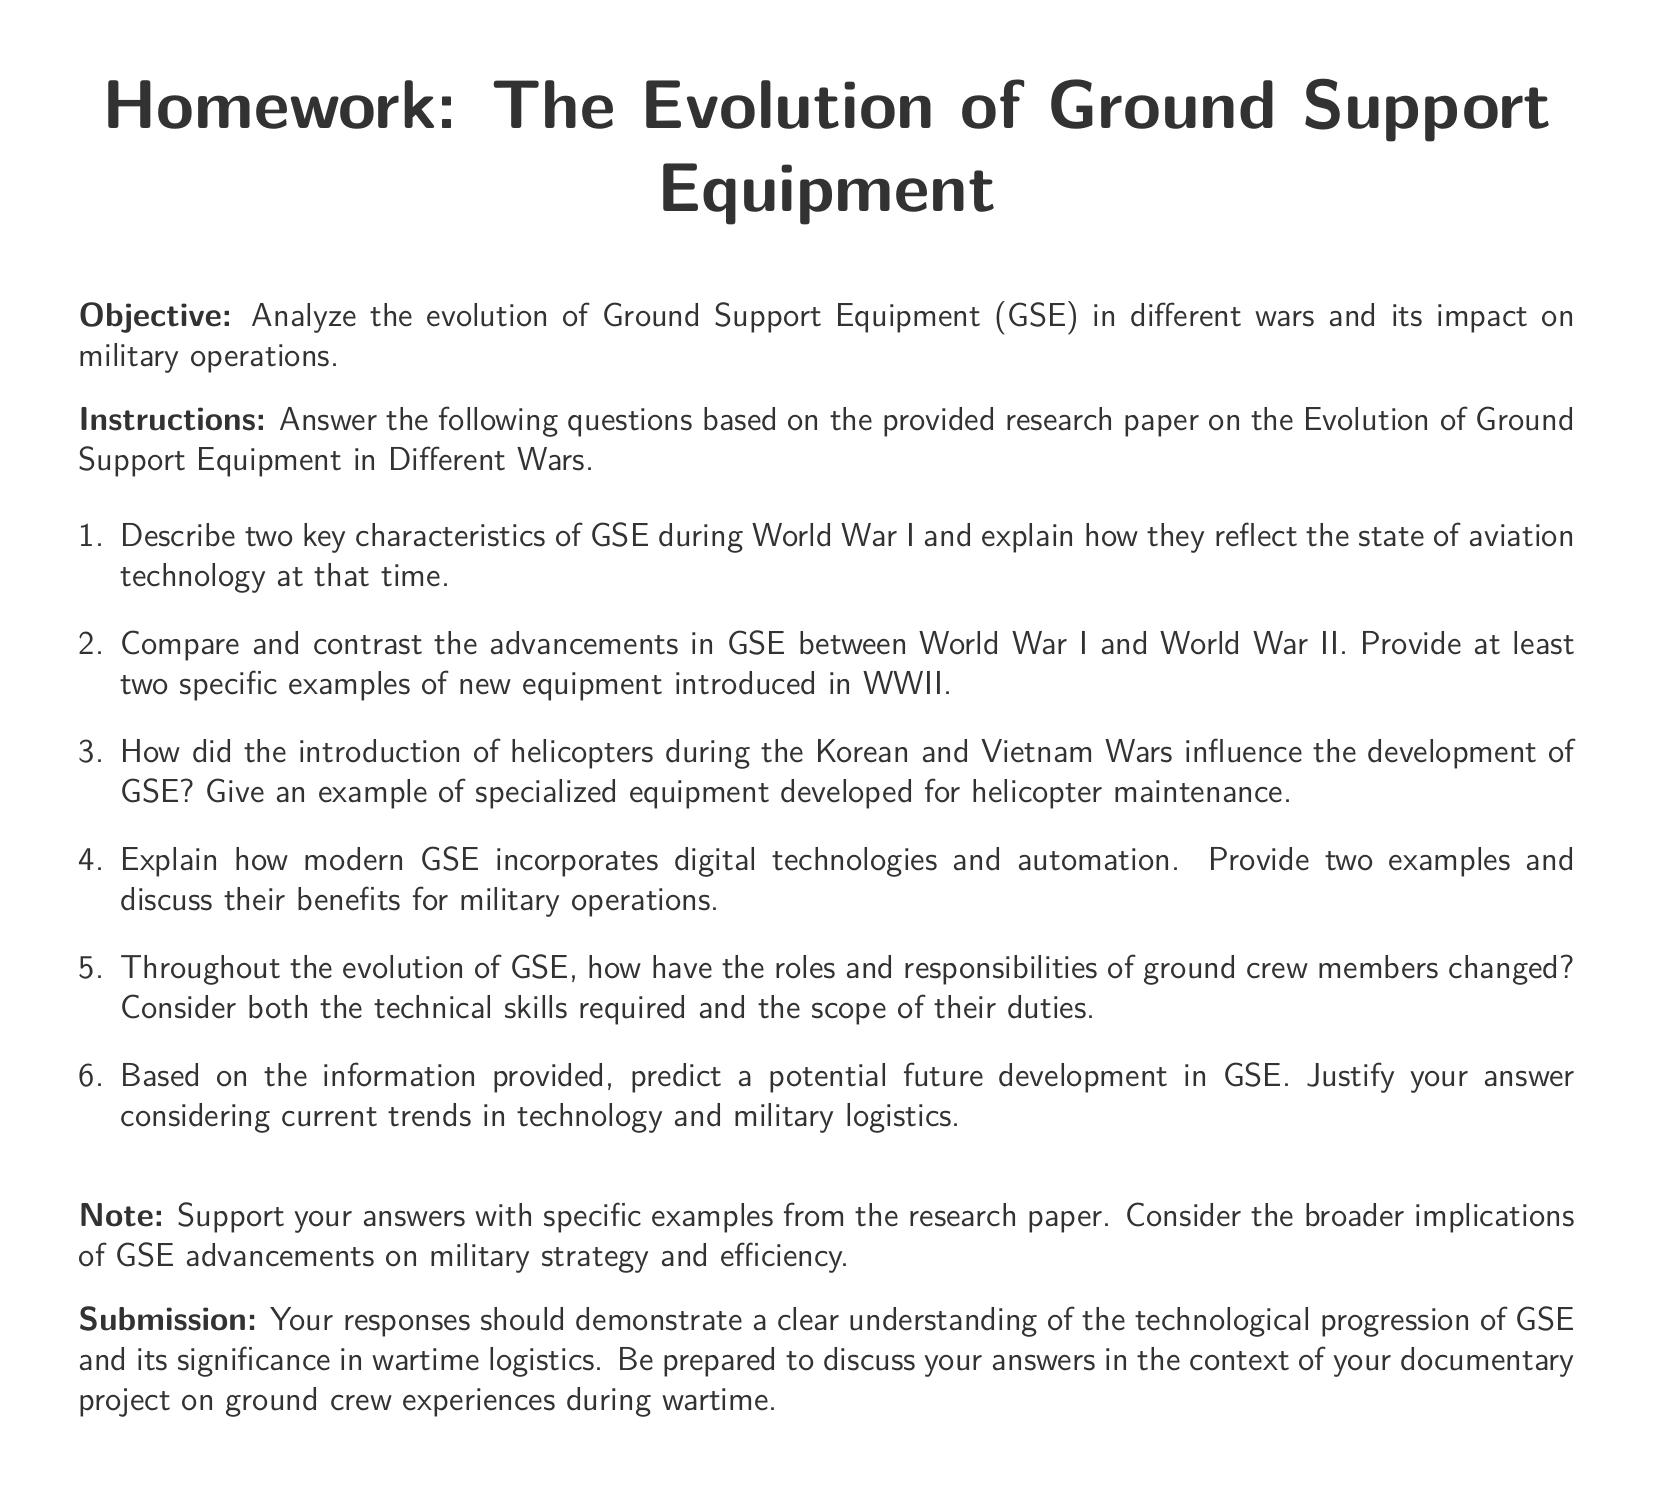What is the title of the homework? The title of the homework is provided at the beginning of the document as "Homework: The Evolution of Ground Support Equipment."
Answer: Homework: The Evolution of Ground Support Equipment What are the two major wars mentioned in the document for GSE comparison? The document specifically mentions World War I and World War II for the comparison of GSE advancements.
Answer: World War I and World War II What is the objective of the homework? The objective is defined in the document as analyzing the evolution of Ground Support Equipment and its impact on military operations.
Answer: Analyze the evolution of Ground Support Equipment and its impact on military operations In which wars did the introduction of helicopters influence GSE development? The document mentions both the Korean and Vietnam Wars as having significant influences from the introduction of helicopters on GSE development.
Answer: Korean and Vietnam Wars How does the document instruct respondents to support their answers? The document instructs respondents to support their answers with specific examples from the provided research paper.
Answer: With specific examples from the research paper What is one role that has changed for ground crew members over time? The document invites consideration of how the roles and responsibilities of ground crew members have changed throughout the evolution of GSE, including their technical skills.
Answer: Technical skills What should submissions demonstrate according to the document? The document states that submissions should demonstrate a clear understanding of the technological progression of GSE and its significance in wartime logistics.
Answer: Clear understanding of the technological progression of GSE and its significance in wartime logistics What kind of questions does the homework encourage for discussion? The document encourages preparation for discussing answers in the context of a documentary project on ground crew experiences during wartime.
Answer: Ground crew experiences during wartime 